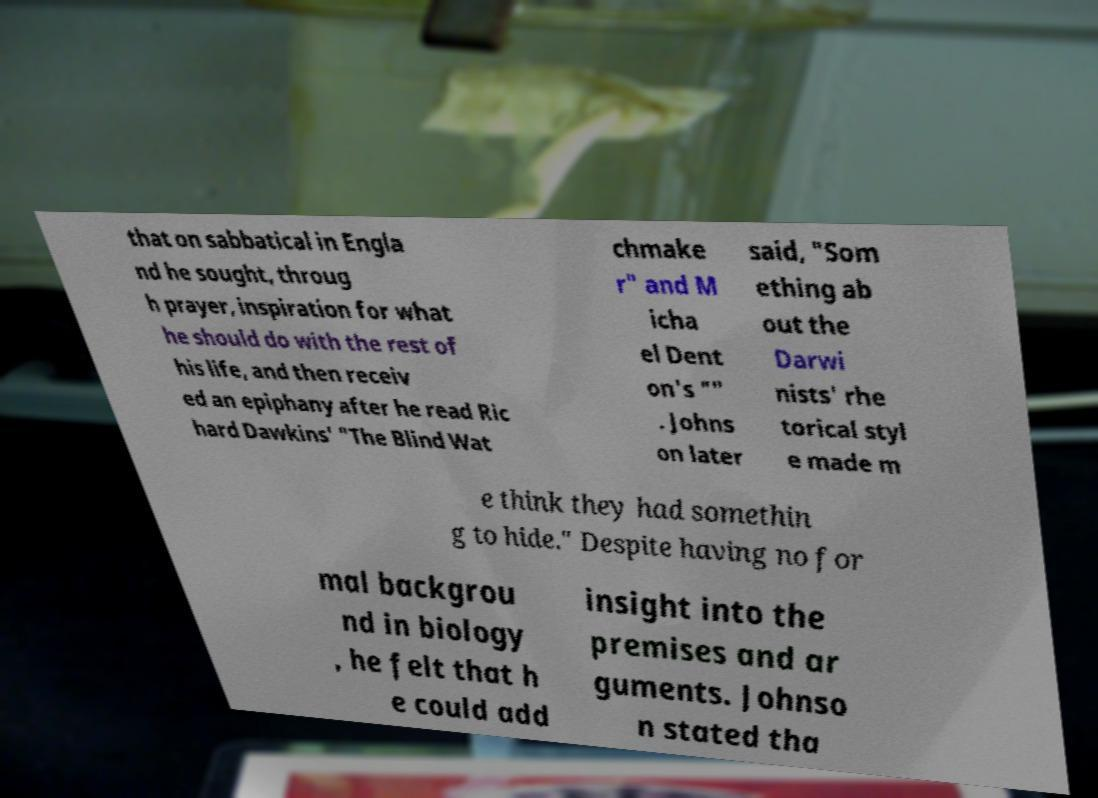Can you read and provide the text displayed in the image?This photo seems to have some interesting text. Can you extract and type it out for me? that on sabbatical in Engla nd he sought, throug h prayer, inspiration for what he should do with the rest of his life, and then receiv ed an epiphany after he read Ric hard Dawkins' "The Blind Wat chmake r" and M icha el Dent on's "" . Johns on later said, "Som ething ab out the Darwi nists' rhe torical styl e made m e think they had somethin g to hide." Despite having no for mal backgrou nd in biology , he felt that h e could add insight into the premises and ar guments. Johnso n stated tha 